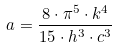<formula> <loc_0><loc_0><loc_500><loc_500>a = \frac { 8 \cdot \pi ^ { 5 } \cdot k ^ { 4 } } { 1 5 \cdot h ^ { 3 } \cdot c ^ { 3 } }</formula> 